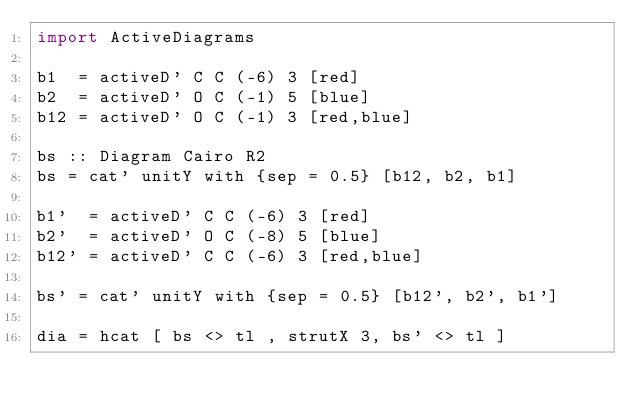Convert code to text. <code><loc_0><loc_0><loc_500><loc_500><_Haskell_>import ActiveDiagrams

b1  = activeD' C C (-6) 3 [red]
b2  = activeD' O C (-1) 5 [blue]
b12 = activeD' O C (-1) 3 [red,blue]

bs :: Diagram Cairo R2
bs = cat' unitY with {sep = 0.5} [b12, b2, b1]

b1'  = activeD' C C (-6) 3 [red]
b2'  = activeD' O C (-8) 5 [blue]
b12' = activeD' C C (-6) 3 [red,blue]

bs' = cat' unitY with {sep = 0.5} [b12', b2', b1']

dia = hcat [ bs <> tl , strutX 3, bs' <> tl ]
</code> 